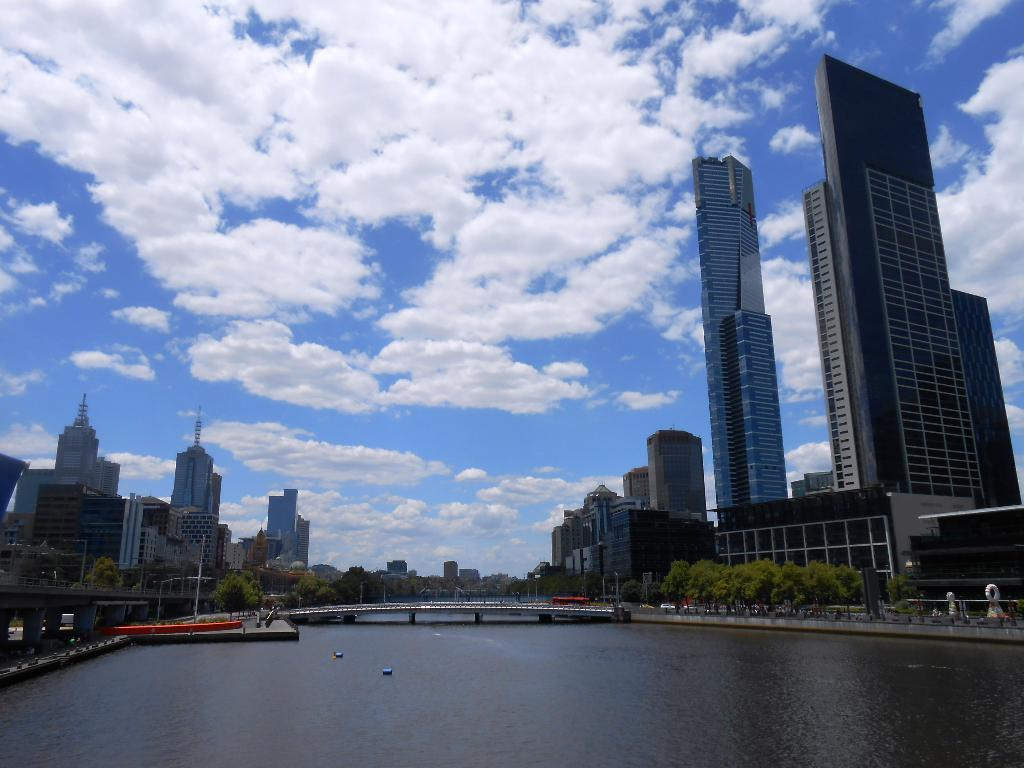What is the main feature of the landscape in the image? There is a big river in the image. How does the river connect different parts of the landscape? The bridge over the river connects different parts of the landscape. What type of vegetation can be seen in the image? There are trees visible in the image. What type of structures are visible in the image? There are buildings visible in the image. What is the name of the leather item being used by the river in the image? There is no leather item present in the image, and the river is not an entity that can use items. 